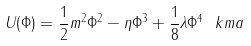Convert formula to latex. <formula><loc_0><loc_0><loc_500><loc_500>U ( \Phi ) = \frac { 1 } { 2 } m ^ { 2 } \Phi ^ { 2 } - \eta \Phi ^ { 3 } + \frac { 1 } { 8 } \lambda \Phi ^ { 4 } \ k m a</formula> 